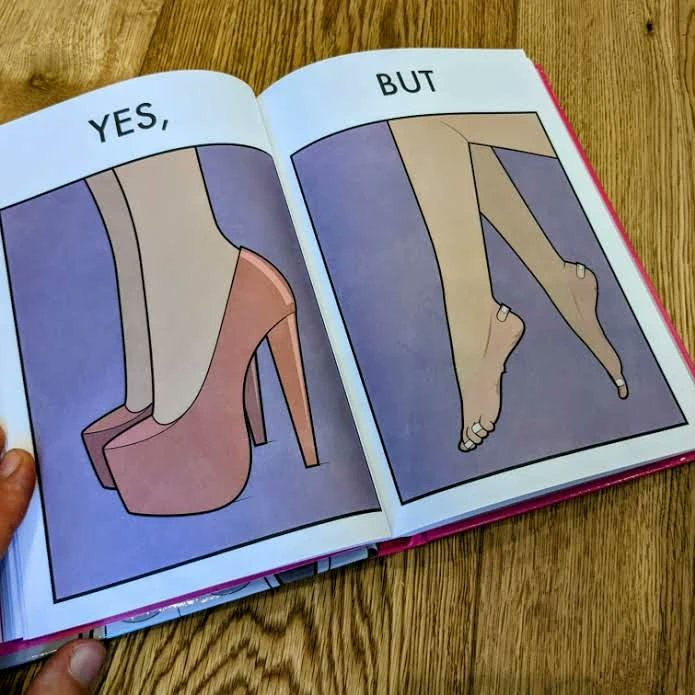Is this image satirical or non-satirical? Yes, this image is satirical. 